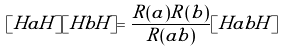Convert formula to latex. <formula><loc_0><loc_0><loc_500><loc_500>[ H a H ] [ H b H ] = \frac { R ( a ) R ( b ) } { R ( a b ) } [ H a b H ]</formula> 